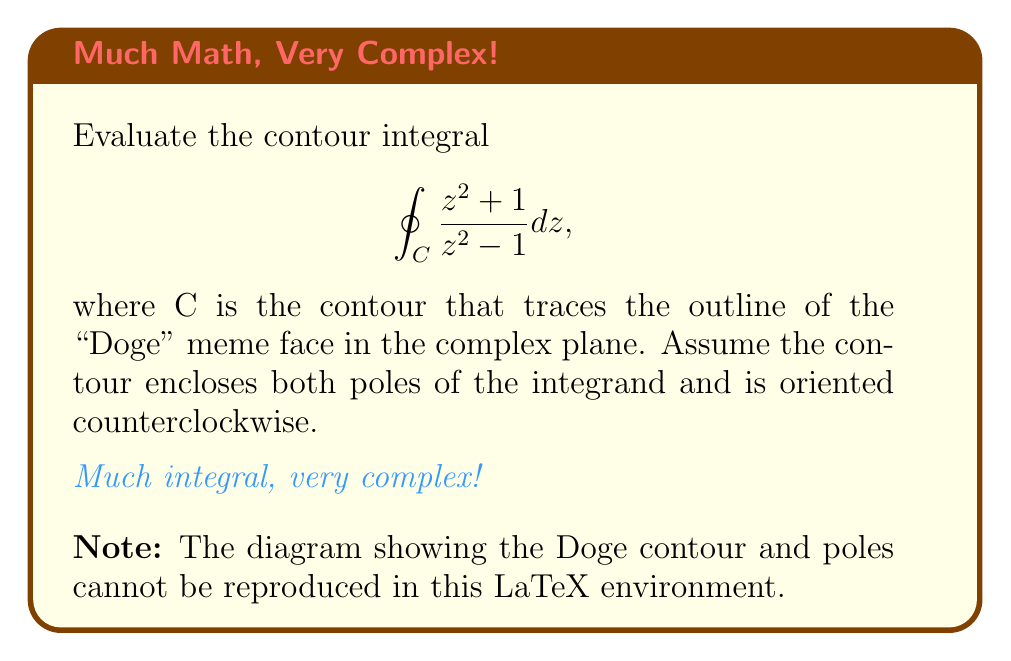Teach me how to tackle this problem. Let's approach this integral with the enthusiasm of a meme lord, shall we? 

1) First, we observe that the integrand $f(z) = \frac{z^2 + 1}{z^2 - 1}$ has poles at $z = \pm 1$. These poles are simple poles, much like the simple joy of a good meme.

2) We can use the residue theorem, which states:

   $\oint_C f(z) dz = 2\pi i \sum_{k=1}^n \text{Res}(f, z_k)$

   where $z_k$ are the poles enclosed by the contour.

3) To find the residues, we use the formula for simple poles:

   $\text{Res}(f, z_k) = \lim_{z \to z_k} (z - z_k)f(z)$

4) For $z = 1$:
   
   $\text{Res}(f, 1) = \lim_{z \to 1} (z-1)\frac{z^2 + 1}{z^2 - 1} = \lim_{z \to 1} \frac{z^2 + 1}{z+1} = 1$

5) For $z = -1$:
   
   $\text{Res}(f, -1) = \lim_{z \to -1} (z+1)\frac{z^2 + 1}{z^2 - 1} = \lim_{z \to -1} \frac{z^2 + 1}{z-1} = -1$

6) Summing the residues:

   $\sum_{k=1}^n \text{Res}(f, z_k) = 1 + (-1) = 0$

7) Applying the residue theorem:

   $\oint_C f(z) dz = 2\pi i \cdot 0 = 0$

And there you have it! The integral evaluates to zero, much like the number of regrets one should have when sharing a quality meme. As Oscar Wilde might say if he were alive today, "Life is far too important a thing ever to talk seriously about... especially when there are memes to be made."
Answer: $0$ 